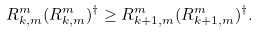Convert formula to latex. <formula><loc_0><loc_0><loc_500><loc_500>R ^ { m } _ { k , m } ( R ^ { m } _ { k , m } ) ^ { \dagger } \geq R ^ { m } _ { k + 1 , m } ( R ^ { m } _ { k + 1 , m } ) ^ { \dagger } .</formula> 